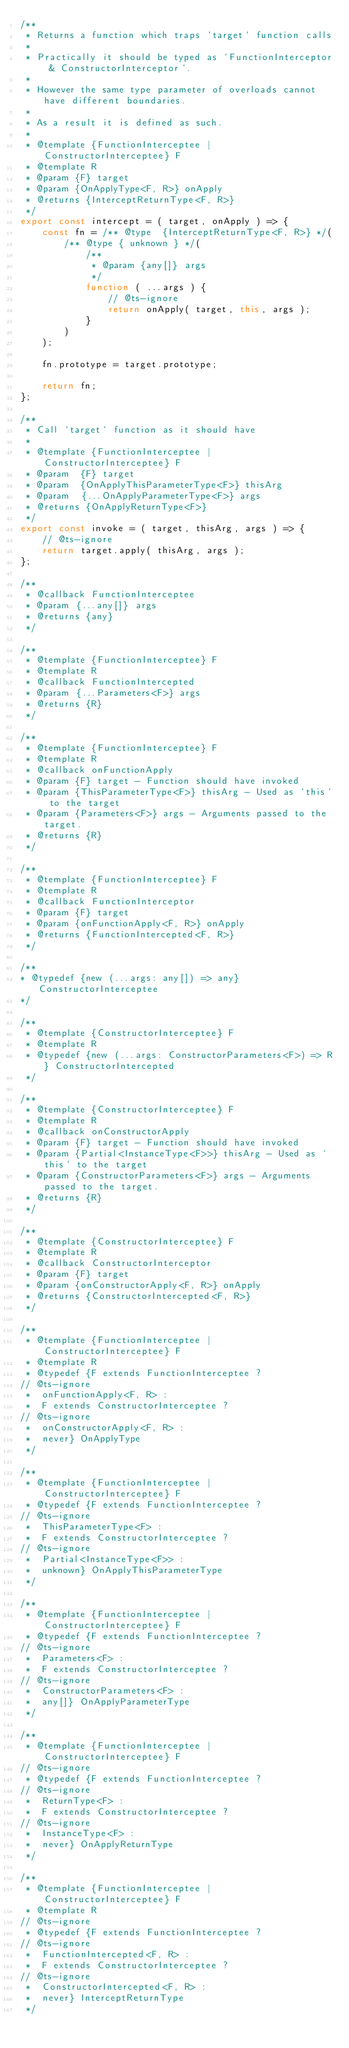Convert code to text. <code><loc_0><loc_0><loc_500><loc_500><_JavaScript_>/**
 * Returns a function which traps `target` function calls
 *
 * Practically it should be typed as `FunctionInterceptor & ConstructorInterceptor`.
 *
 * However the same type parameter of overloads cannot have different boundaries.
 *
 * As a result it is defined as such.
 *
 * @template {FunctionInterceptee | ConstructorInterceptee} F
 * @template R
 * @param {F} target
 * @param {OnApplyType<F, R>} onApply
 * @returns {InterceptReturnType<F, R>}
 */
export const intercept = ( target, onApply ) => {
	const fn = /** @type  {InterceptReturnType<F, R>} */(
		/** @type { unknown } */(
			/**
			 * @param {any[]} args
			 */
			function ( ...args ) {
				// @ts-ignore
				return onApply( target, this, args );
			}
		)
	);

	fn.prototype = target.prototype;

	return fn;
};

/**
 * Call `target` function as it should have
 *
 * @template {FunctionInterceptee | ConstructorInterceptee} F
 * @param  {F} target
 * @param  {OnApplyThisParameterType<F>} thisArg
 * @param  {...OnApplyParameterType<F>} args
 * @returns {OnApplyReturnType<F>}
 */
export const invoke = ( target, thisArg, args ) => {
	// @ts-ignore
	return target.apply( thisArg, args );
};

/**
 * @callback FunctionInterceptee
 * @param {...any[]} args
 * @returns {any}
 */

/**
 * @template {FunctionInterceptee} F
 * @template R
 * @callback FunctionIntercepted
 * @param {...Parameters<F>} args
 * @returns {R}
 */

/**
 * @template {FunctionInterceptee} F
 * @template R
 * @callback onFunctionApply
 * @param {F} target - Function should have invoked
 * @param {ThisParameterType<F>} thisArg - Used as `this` to the target
 * @param {Parameters<F>} args - Arguments passed to the target.
 * @returns {R}
 */

/**
 * @template {FunctionInterceptee} F
 * @template R
 * @callback FunctionInterceptor
 * @param {F} target
 * @param {onFunctionApply<F, R>} onApply
 * @returns {FunctionIntercepted<F, R>}
 */

/**
* @typedef {new (...args: any[]) => any} ConstructorInterceptee
*/

/**
 * @template {ConstructorInterceptee} F
 * @template R
 * @typedef {new (...args: ConstructorParameters<F>) => R} ConstructorIntercepted
 */

/**
 * @template {ConstructorInterceptee} F
 * @template R
 * @callback onConstructorApply
 * @param {F} target - Function should have invoked
 * @param {Partial<InstanceType<F>>} thisArg - Used as `this` to the target
 * @param {ConstructorParameters<F>} args - Arguments passed to the target.
 * @returns {R}
 */

/**
 * @template {ConstructorInterceptee} F
 * @template R
 * @callback ConstructorInterceptor
 * @param {F} target
 * @param {onConstructorApply<F, R>} onApply
 * @returns {ConstructorIntercepted<F, R>}
 */

/**
 * @template {FunctionInterceptee | ConstructorInterceptee} F
 * @template R
 * @typedef {F extends FunctionInterceptee ?
// @ts-ignore
 * 	onFunctionApply<F, R> :
 * 	F extends ConstructorInterceptee ?
// @ts-ignore
 * 	onConstructorApply<F, R> :
 * 	never} OnApplyType
 */

/**
 * @template {FunctionInterceptee | ConstructorInterceptee} F
 * @typedef {F extends FunctionInterceptee ?
// @ts-ignore
 * 	ThisParameterType<F> :
 * 	F extends ConstructorInterceptee ?
// @ts-ignore
 * 	Partial<InstanceType<F>> :
 * 	unknown} OnApplyThisParameterType
 */

/**
 * @template {FunctionInterceptee | ConstructorInterceptee} F
 * @typedef {F extends FunctionInterceptee ?
// @ts-ignore
 * 	Parameters<F> :
 * 	F extends ConstructorInterceptee ?
// @ts-ignore
 * 	ConstructorParameters<F> :
 * 	any[]} OnApplyParameterType
 */

/**
 * @template {FunctionInterceptee | ConstructorInterceptee} F
// @ts-ignore
 * @typedef {F extends FunctionInterceptee ?
// @ts-ignore
 * 	ReturnType<F> :
 * 	F extends ConstructorInterceptee ?
// @ts-ignore
 * 	InstanceType<F> :
 * 	never} OnApplyReturnType
 */

/**
 * @template {FunctionInterceptee | ConstructorInterceptee} F
 * @template R
// @ts-ignore
 * @typedef {F extends FunctionInterceptee ?
// @ts-ignore
 * 	FunctionIntercepted<F, R> :
 * 	F extends ConstructorInterceptee ?
// @ts-ignore
 * 	ConstructorIntercepted<F, R> :
 * 	never} InterceptReturnType
 */
</code> 